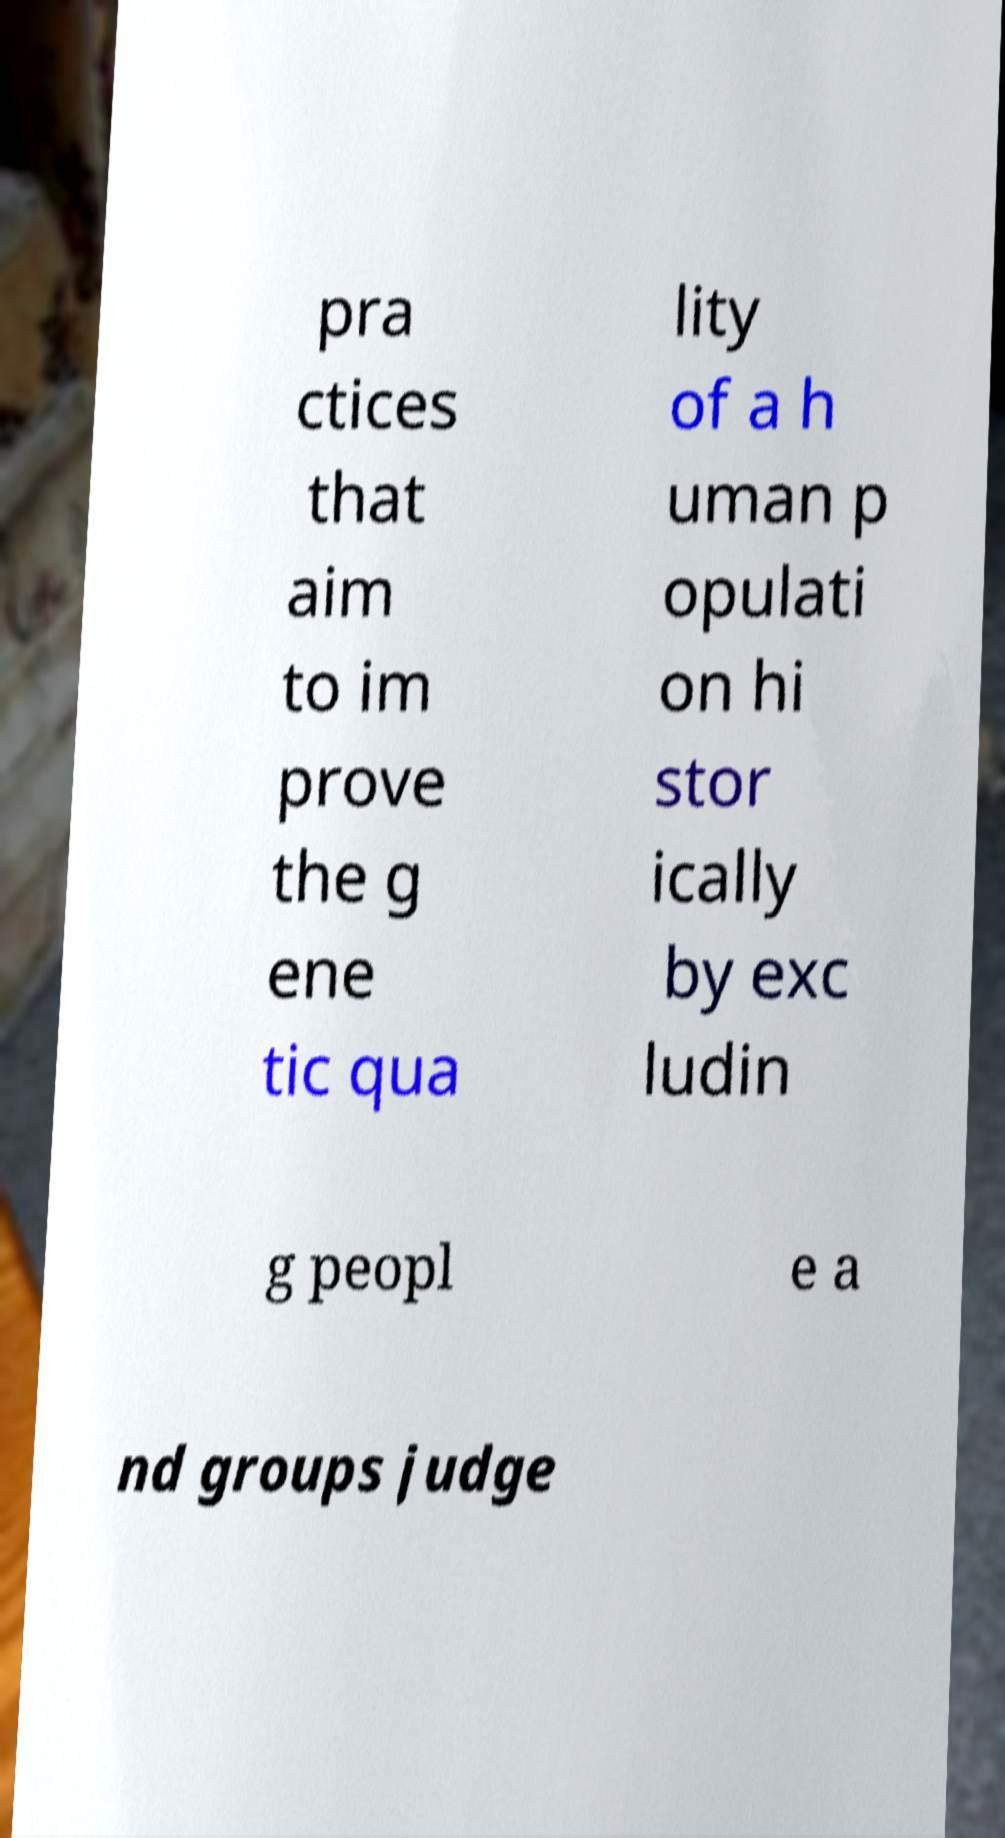Can you read and provide the text displayed in the image?This photo seems to have some interesting text. Can you extract and type it out for me? pra ctices that aim to im prove the g ene tic qua lity of a h uman p opulati on hi stor ically by exc ludin g peopl e a nd groups judge 